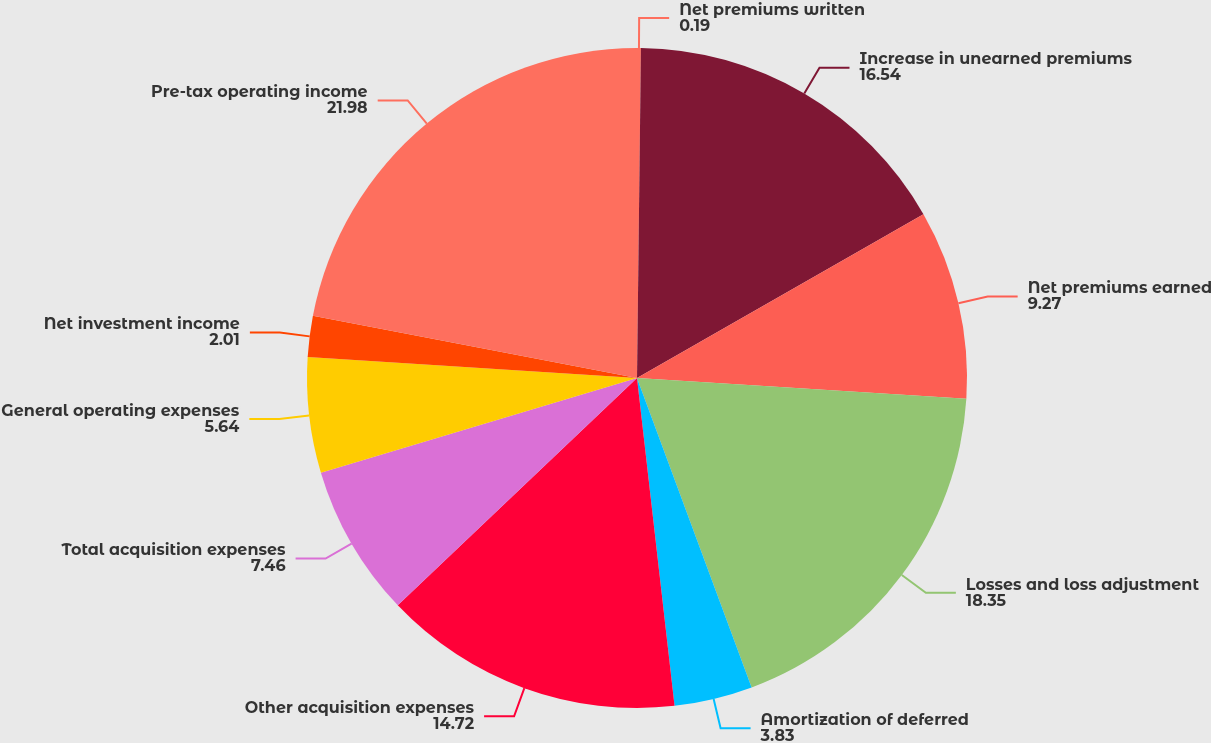<chart> <loc_0><loc_0><loc_500><loc_500><pie_chart><fcel>Net premiums written<fcel>Increase in unearned premiums<fcel>Net premiums earned<fcel>Losses and loss adjustment<fcel>Amortization of deferred<fcel>Other acquisition expenses<fcel>Total acquisition expenses<fcel>General operating expenses<fcel>Net investment income<fcel>Pre-tax operating income<nl><fcel>0.19%<fcel>16.54%<fcel>9.27%<fcel>18.35%<fcel>3.83%<fcel>14.72%<fcel>7.46%<fcel>5.64%<fcel>2.01%<fcel>21.98%<nl></chart> 